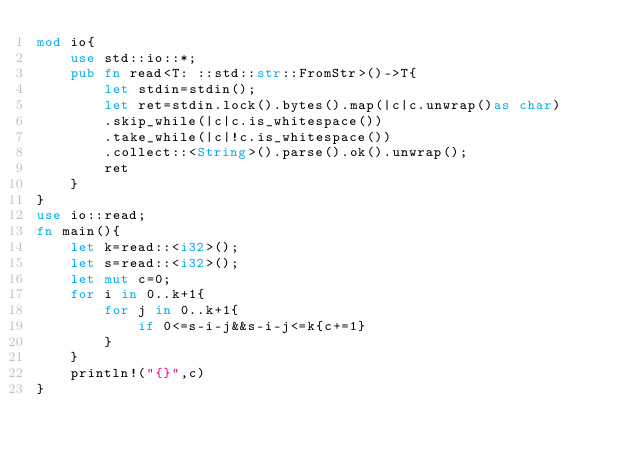<code> <loc_0><loc_0><loc_500><loc_500><_Rust_>mod io{
    use std::io::*;
    pub fn read<T: ::std::str::FromStr>()->T{
        let stdin=stdin();
        let ret=stdin.lock().bytes().map(|c|c.unwrap()as char)
        .skip_while(|c|c.is_whitespace())
        .take_while(|c|!c.is_whitespace())
        .collect::<String>().parse().ok().unwrap();
        ret
    }
}
use io::read;
fn main(){
    let k=read::<i32>();
    let s=read::<i32>();
    let mut c=0;
    for i in 0..k+1{
        for j in 0..k+1{
            if 0<=s-i-j&&s-i-j<=k{c+=1}
        }
    }
    println!("{}",c)
}
</code> 